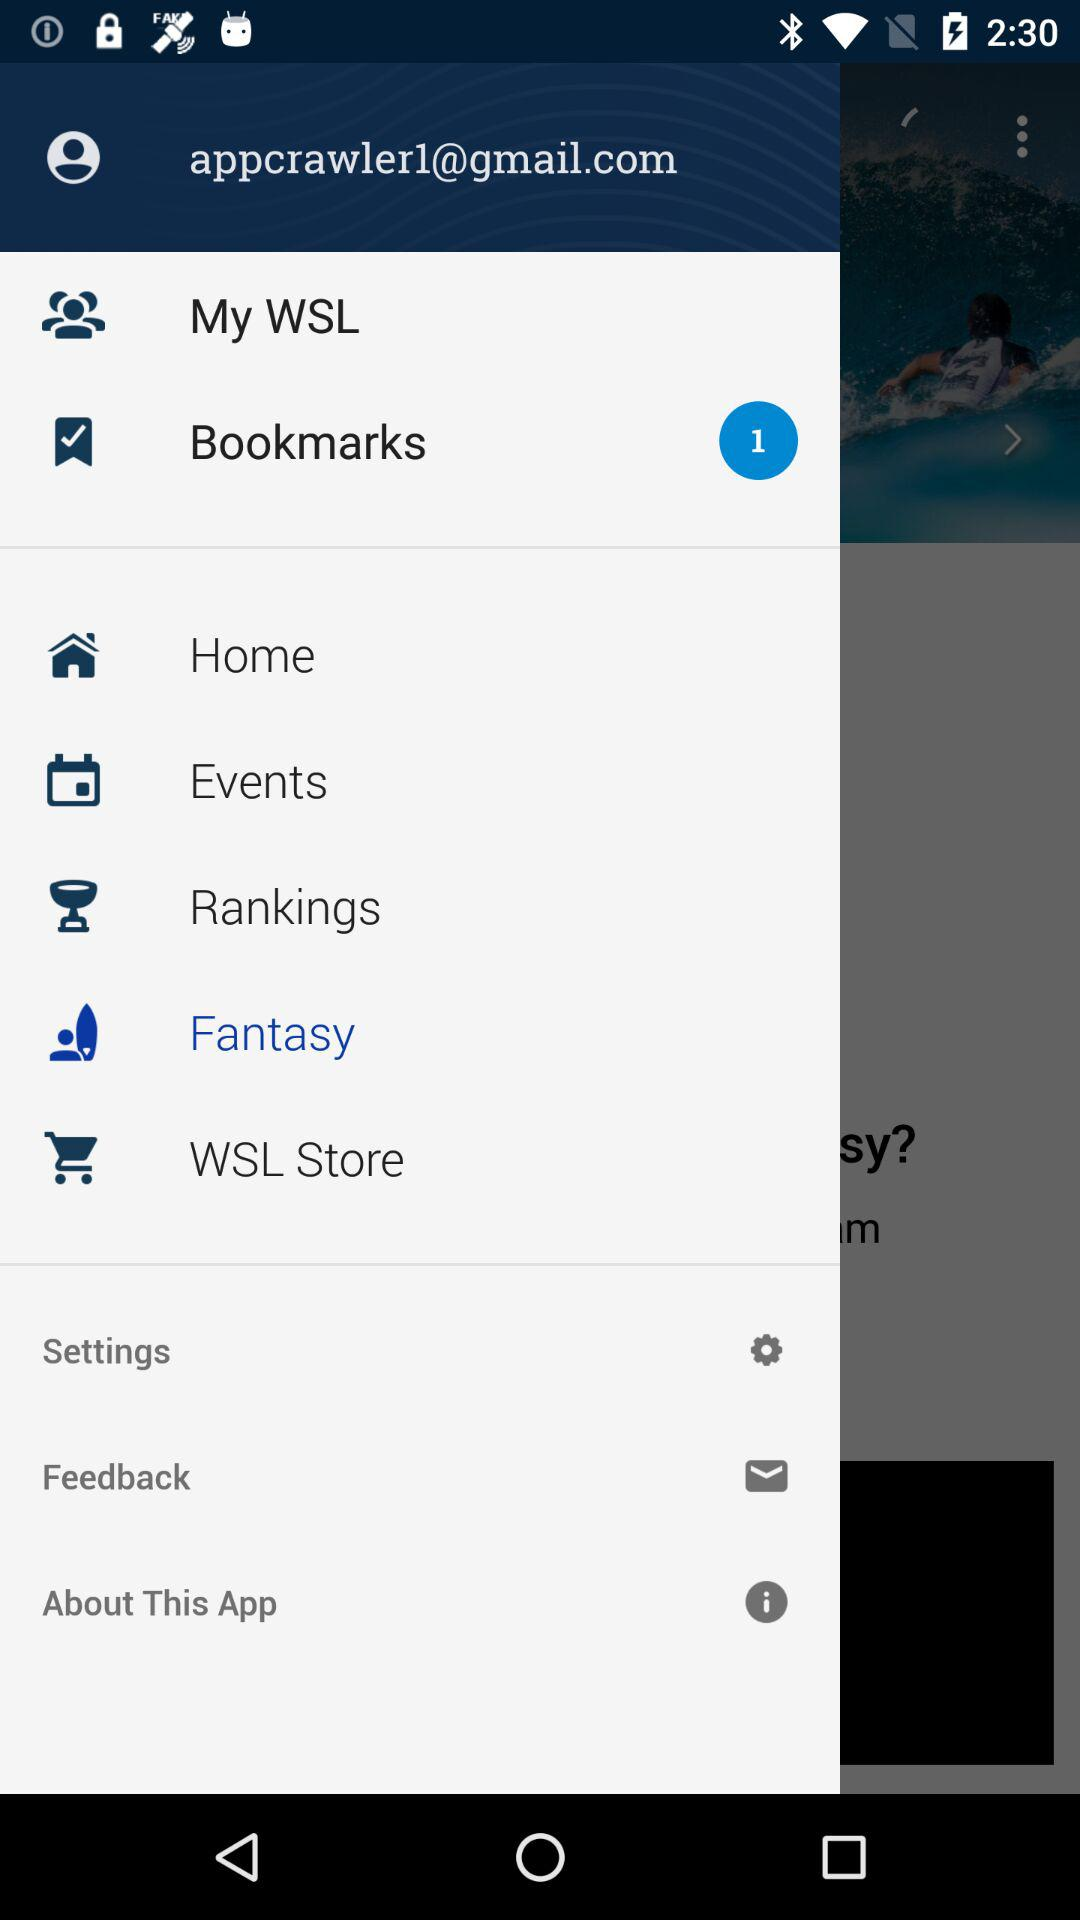What is the selected option? The selected option is "Fantasy". 